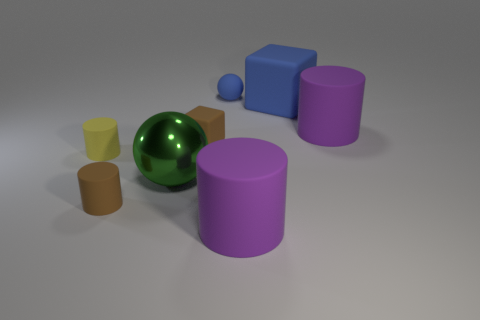Is there anything else that has the same size as the metallic object?
Your answer should be very brief. Yes. Are there more small green things than small cubes?
Ensure brevity in your answer.  No. There is a cylinder that is both left of the blue ball and on the right side of the yellow cylinder; what is its size?
Your response must be concise. Small. What is the shape of the big green thing?
Provide a succinct answer. Sphere. How many blue objects have the same shape as the green metal object?
Ensure brevity in your answer.  1. Is the number of small matte cylinders that are in front of the tiny brown matte cylinder less than the number of brown blocks behind the small ball?
Ensure brevity in your answer.  No. There is a large shiny thing in front of the big blue rubber cube; what number of large rubber blocks are on the right side of it?
Your response must be concise. 1. Are any tiny rubber objects visible?
Your response must be concise. Yes. Is there a small cube made of the same material as the big green ball?
Your response must be concise. No. Are there more tiny rubber cubes in front of the large sphere than brown rubber cubes left of the rubber ball?
Give a very brief answer. No. 